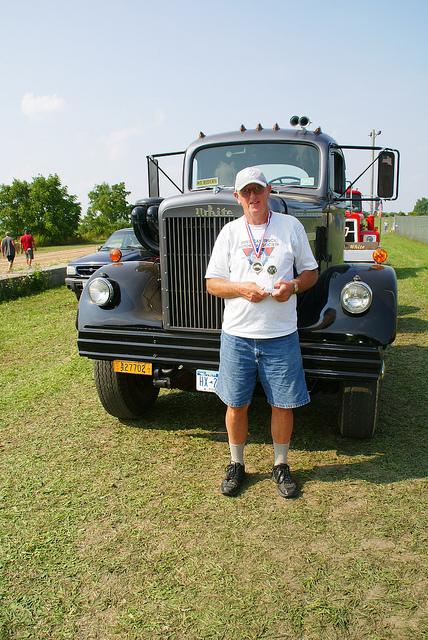Has the older truck been well maintained mechanically?
Give a very brief answer. Yes. What kind of pants is the man wearing?
Give a very brief answer. Shorts. What color are the man's shoes?
Short answer required. Black. 